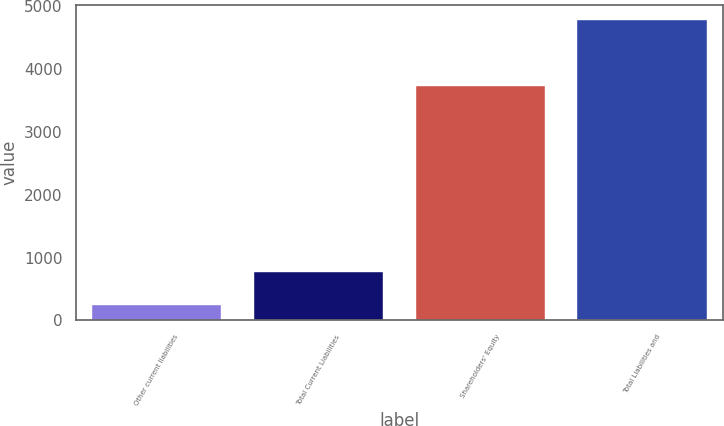Convert chart to OTSL. <chart><loc_0><loc_0><loc_500><loc_500><bar_chart><fcel>Other current liabilities<fcel>Total Current Liabilities<fcel>Shareholders' Equity<fcel>Total Liabilities and<nl><fcel>251<fcel>766<fcel>3732<fcel>4782<nl></chart> 